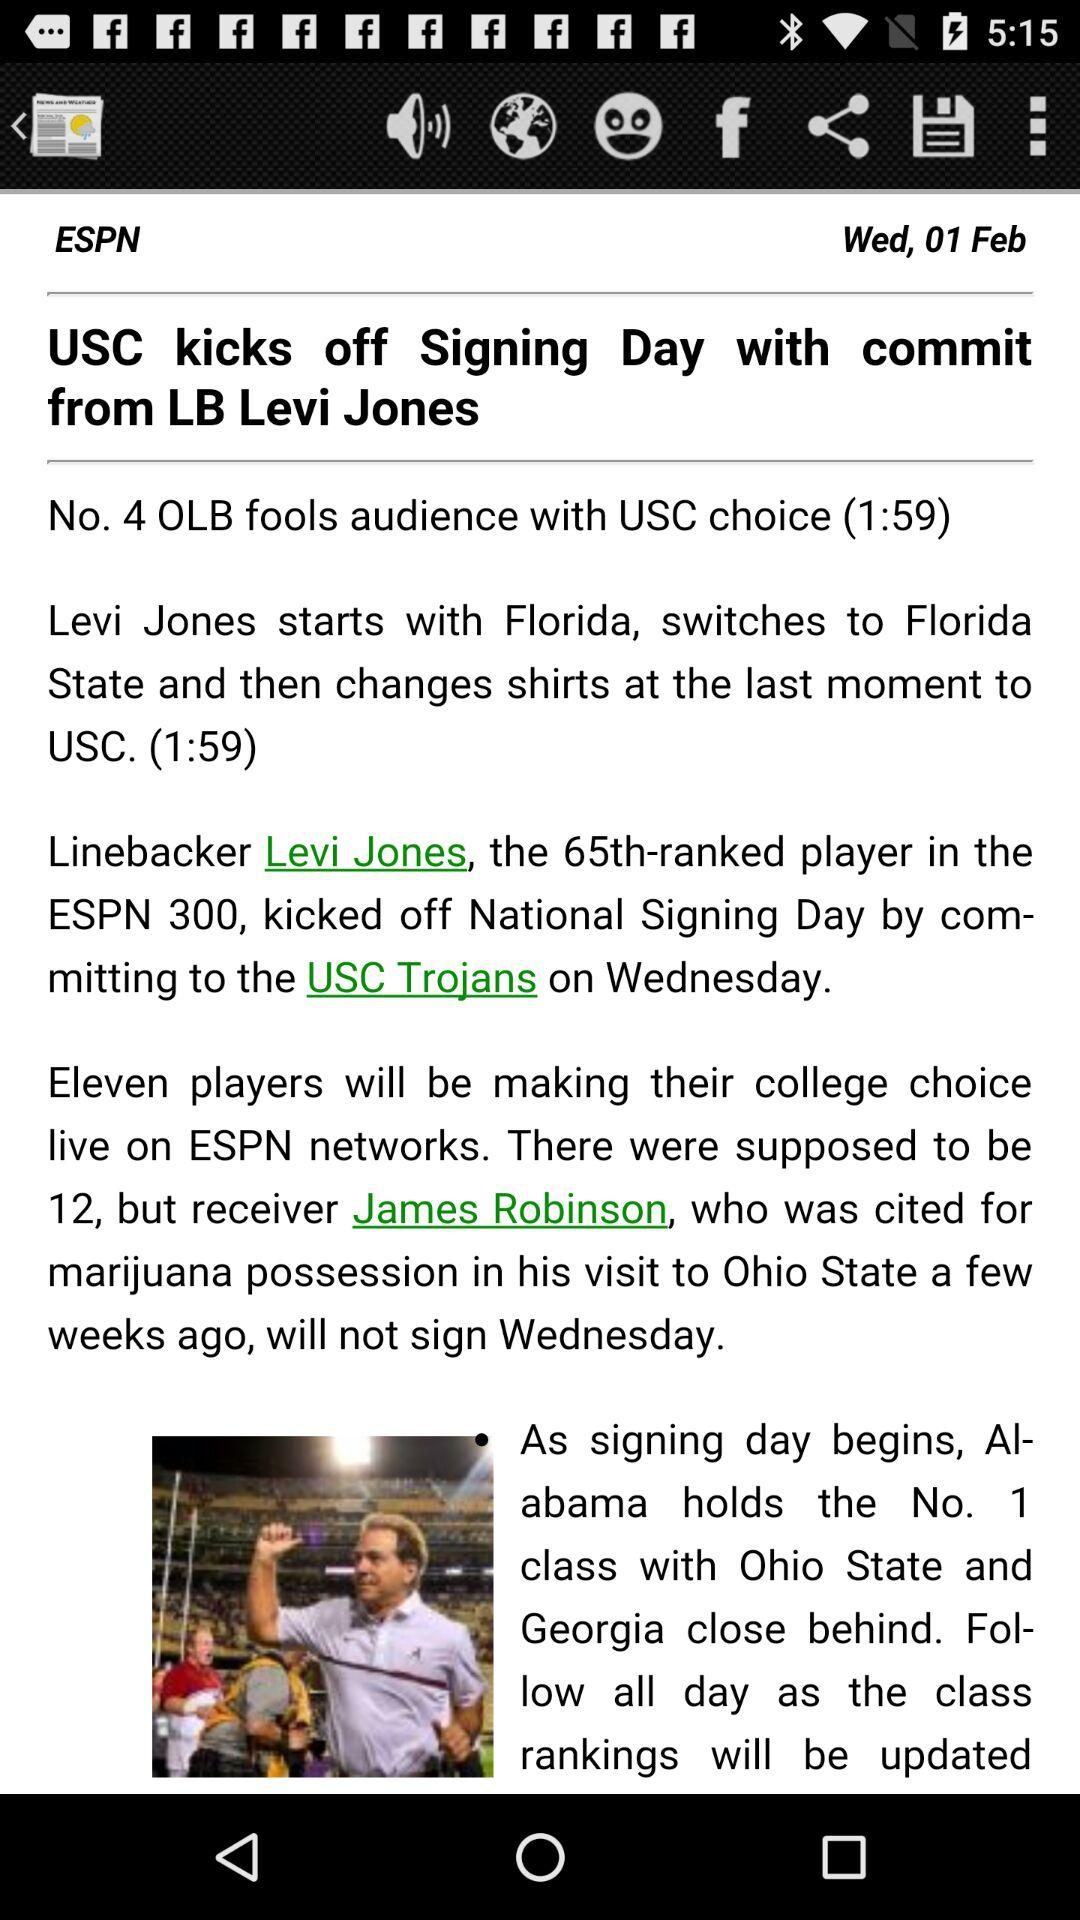What is the current location?
When the provided information is insufficient, respond with <no answer>. <no answer> 